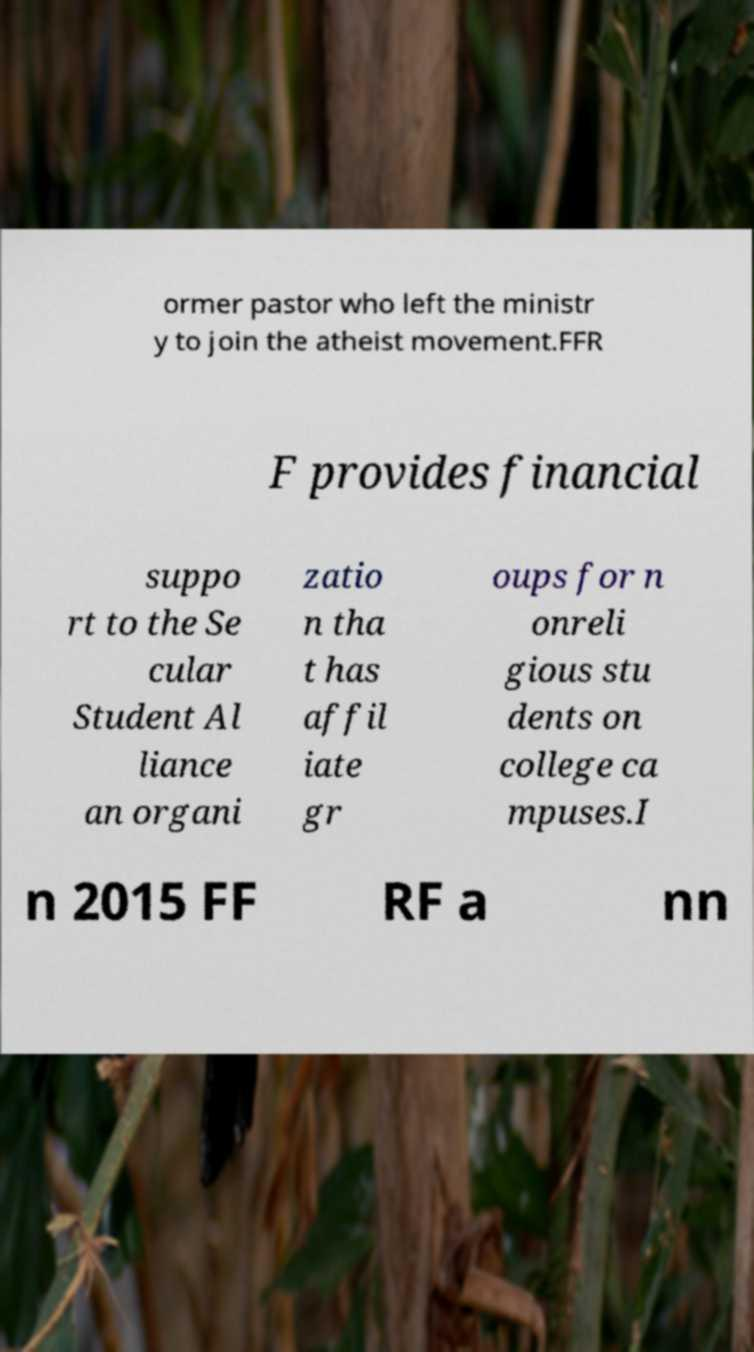Please read and relay the text visible in this image. What does it say? ormer pastor who left the ministr y to join the atheist movement.FFR F provides financial suppo rt to the Se cular Student Al liance an organi zatio n tha t has affil iate gr oups for n onreli gious stu dents on college ca mpuses.I n 2015 FF RF a nn 